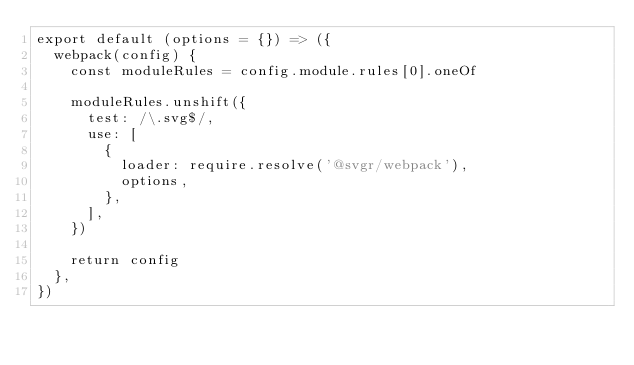Convert code to text. <code><loc_0><loc_0><loc_500><loc_500><_JavaScript_>export default (options = {}) => ({
  webpack(config) {
    const moduleRules = config.module.rules[0].oneOf

    moduleRules.unshift({
      test: /\.svg$/,
      use: [
        {
          loader: require.resolve('@svgr/webpack'),
          options,
        },
      ],
    })

    return config
  },
})
</code> 